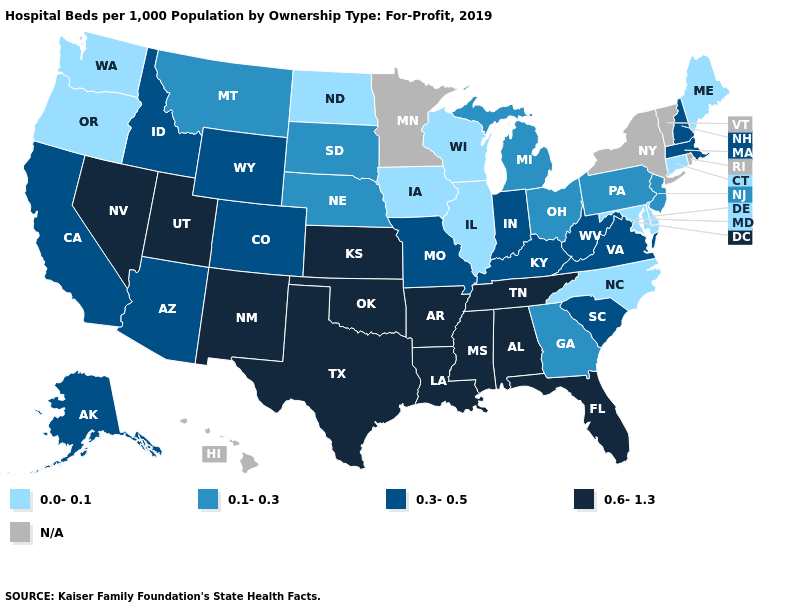What is the lowest value in states that border Oregon?
Concise answer only. 0.0-0.1. What is the value of Arizona?
Be succinct. 0.3-0.5. Is the legend a continuous bar?
Give a very brief answer. No. Among the states that border Florida , which have the highest value?
Quick response, please. Alabama. Name the states that have a value in the range 0.1-0.3?
Keep it brief. Georgia, Michigan, Montana, Nebraska, New Jersey, Ohio, Pennsylvania, South Dakota. What is the value of Mississippi?
Quick response, please. 0.6-1.3. Name the states that have a value in the range N/A?
Quick response, please. Hawaii, Minnesota, New York, Rhode Island, Vermont. Name the states that have a value in the range 0.6-1.3?
Give a very brief answer. Alabama, Arkansas, Florida, Kansas, Louisiana, Mississippi, Nevada, New Mexico, Oklahoma, Tennessee, Texas, Utah. Does the map have missing data?
Write a very short answer. Yes. Name the states that have a value in the range 0.1-0.3?
Answer briefly. Georgia, Michigan, Montana, Nebraska, New Jersey, Ohio, Pennsylvania, South Dakota. What is the value of Massachusetts?
Answer briefly. 0.3-0.5. Which states hav the highest value in the MidWest?
Give a very brief answer. Kansas. 